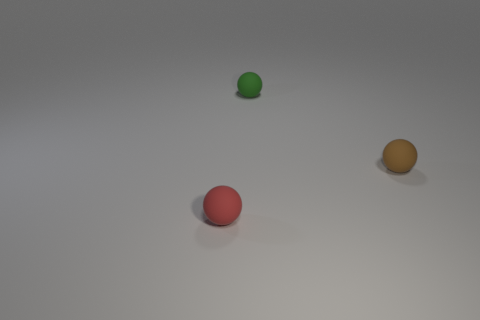What number of objects are tiny spheres that are in front of the small brown rubber ball or objects in front of the small brown matte sphere?
Your answer should be very brief. 1. There is a tiny thing left of the tiny green sphere; is its color the same as the matte ball that is to the right of the tiny green rubber thing?
Provide a short and direct response. No. There is a matte thing behind the tiny brown sphere; does it have the same size as the rubber sphere that is left of the green ball?
Give a very brief answer. Yes. There is a tiny object that is both on the left side of the brown thing and right of the tiny red thing; what material is it made of?
Your answer should be compact. Rubber. How many other things are there of the same size as the red rubber object?
Make the answer very short. 2. There is a thing in front of the tiny brown sphere; what material is it?
Offer a terse response. Rubber. Is the brown rubber object the same shape as the green object?
Keep it short and to the point. Yes. How many other objects are the same shape as the green thing?
Provide a succinct answer. 2. There is a tiny matte ball left of the small green matte ball; what is its color?
Keep it short and to the point. Red. Does the green rubber sphere have the same size as the red ball?
Your response must be concise. Yes. 